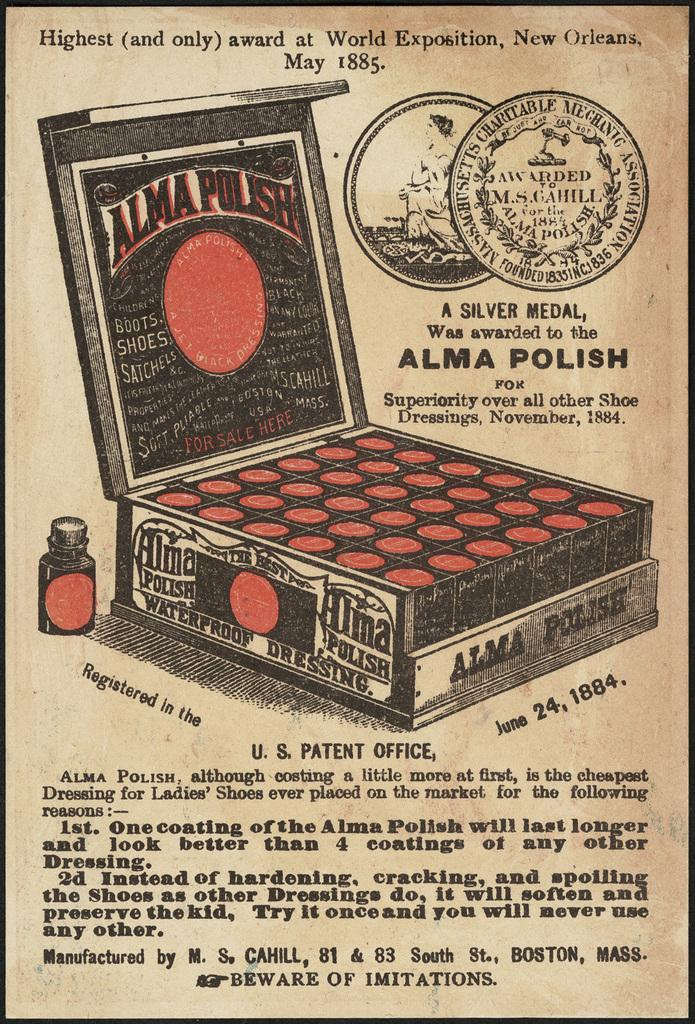<image>
Offer a succinct explanation of the picture presented. a paper that says 'alma polish' on it 